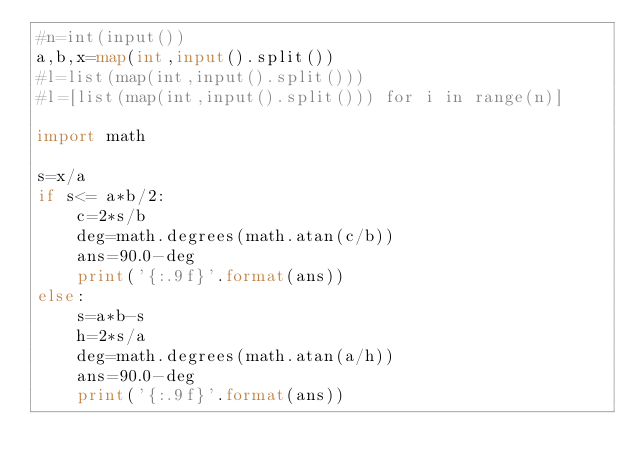Convert code to text. <code><loc_0><loc_0><loc_500><loc_500><_Python_>#n=int(input())
a,b,x=map(int,input().split())
#l=list(map(int,input().split()))
#l=[list(map(int,input().split())) for i in range(n)]

import math

s=x/a
if s<= a*b/2:
    c=2*s/b
    deg=math.degrees(math.atan(c/b))
    ans=90.0-deg
    print('{:.9f}'.format(ans))
else:
    s=a*b-s
    h=2*s/a
    deg=math.degrees(math.atan(a/h))
    ans=90.0-deg
    print('{:.9f}'.format(ans))
</code> 